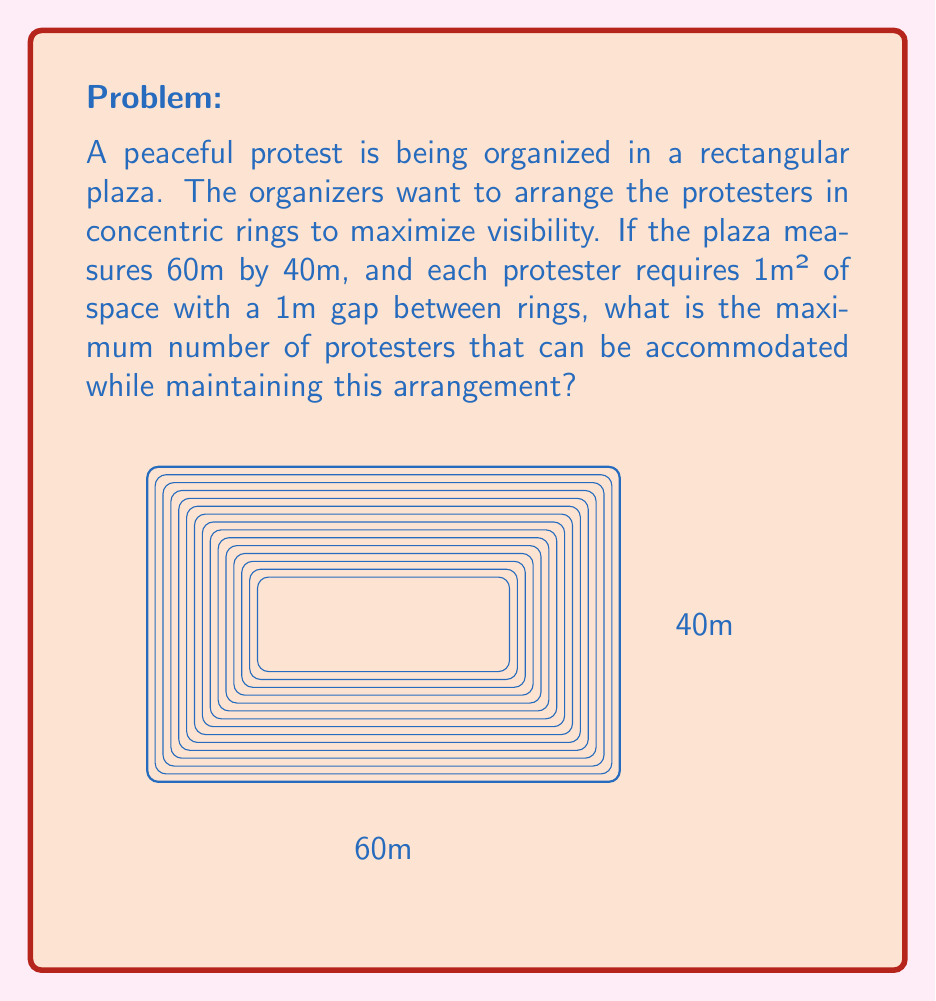Give your solution to this math problem. Let's approach this step-by-step:

1) First, we need to calculate the area of each ring. The outer ring will have dimensions of 60m by 40m, and each subsequent inner ring will be 2m smaller on each side (1m gap on each side).

2) The area of each ring can be calculated using the formula:
   $$A_n = (60-2n+2)(40-2n+2) - (60-2n)(40-2n)$$
   where n is the ring number (1 being the outermost ring).

3) Simplifying this formula:
   $$A_n = 2400 - 200n + 4n^2 - (2400 - 200n + 4n^2 - 4n)$$
   $$A_n = 4n - 4$$

4) Now, we need to find how many rings can fit. The innermost ring should be at least 2m by 2m to accommodate a person. So:
   $$60 - 2n + 2 \geq 2$$ and $$40 - 2n + 2 \geq 2$$
   The second inequality is more restrictive, so:
   $$40 - 2n + 2 \geq 2$$
   $$40 - 2n \geq 0$$
   $$n \leq 20$$

5) Therefore, we can have up to 19 rings (as n starts from 1).

6) Now, let's sum up the areas of all rings:
   $$\sum_{n=1}^{19} (4n - 4) = 4\sum_{n=1}^{19} n - 76$$
   $$= 4 \cdot \frac{19 \cdot 20}{2} - 76 = 760 - 76 = 684$$

7) Since each protester requires 1m² of space, the maximum number of protesters is 684.
Answer: 684 protesters 